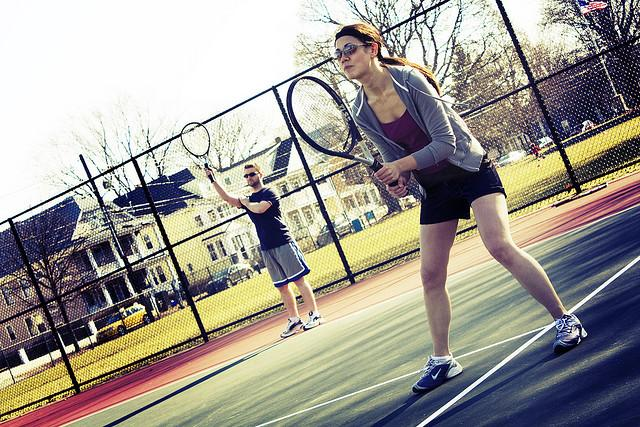What configuration of tennis is being played here? doubles 